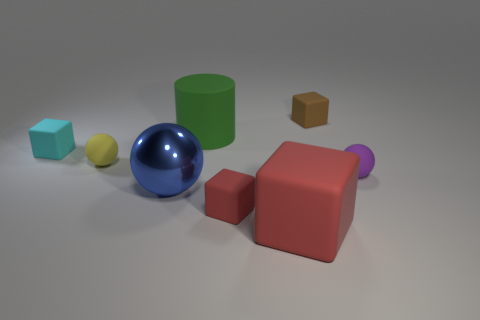How many small matte objects are both in front of the shiny sphere and behind the purple sphere?
Make the answer very short. 0. Do the blue sphere and the cyan object have the same size?
Provide a succinct answer. No. Is the size of the matte sphere that is in front of the yellow rubber ball the same as the big green thing?
Provide a succinct answer. No. There is a tiny object in front of the blue ball; what color is it?
Give a very brief answer. Red. How many small brown rubber blocks are there?
Make the answer very short. 1. There is a big red object that is the same material as the green cylinder; what shape is it?
Your response must be concise. Cube. Do the tiny block that is in front of the small yellow rubber thing and the big rubber object that is in front of the tiny yellow matte thing have the same color?
Provide a short and direct response. Yes. Are there the same number of tiny red matte objects that are left of the tiny yellow ball and big cyan blocks?
Your answer should be compact. Yes. How many small red cubes are to the right of the tiny yellow thing?
Keep it short and to the point. 1. The cyan block is what size?
Offer a terse response. Small. 